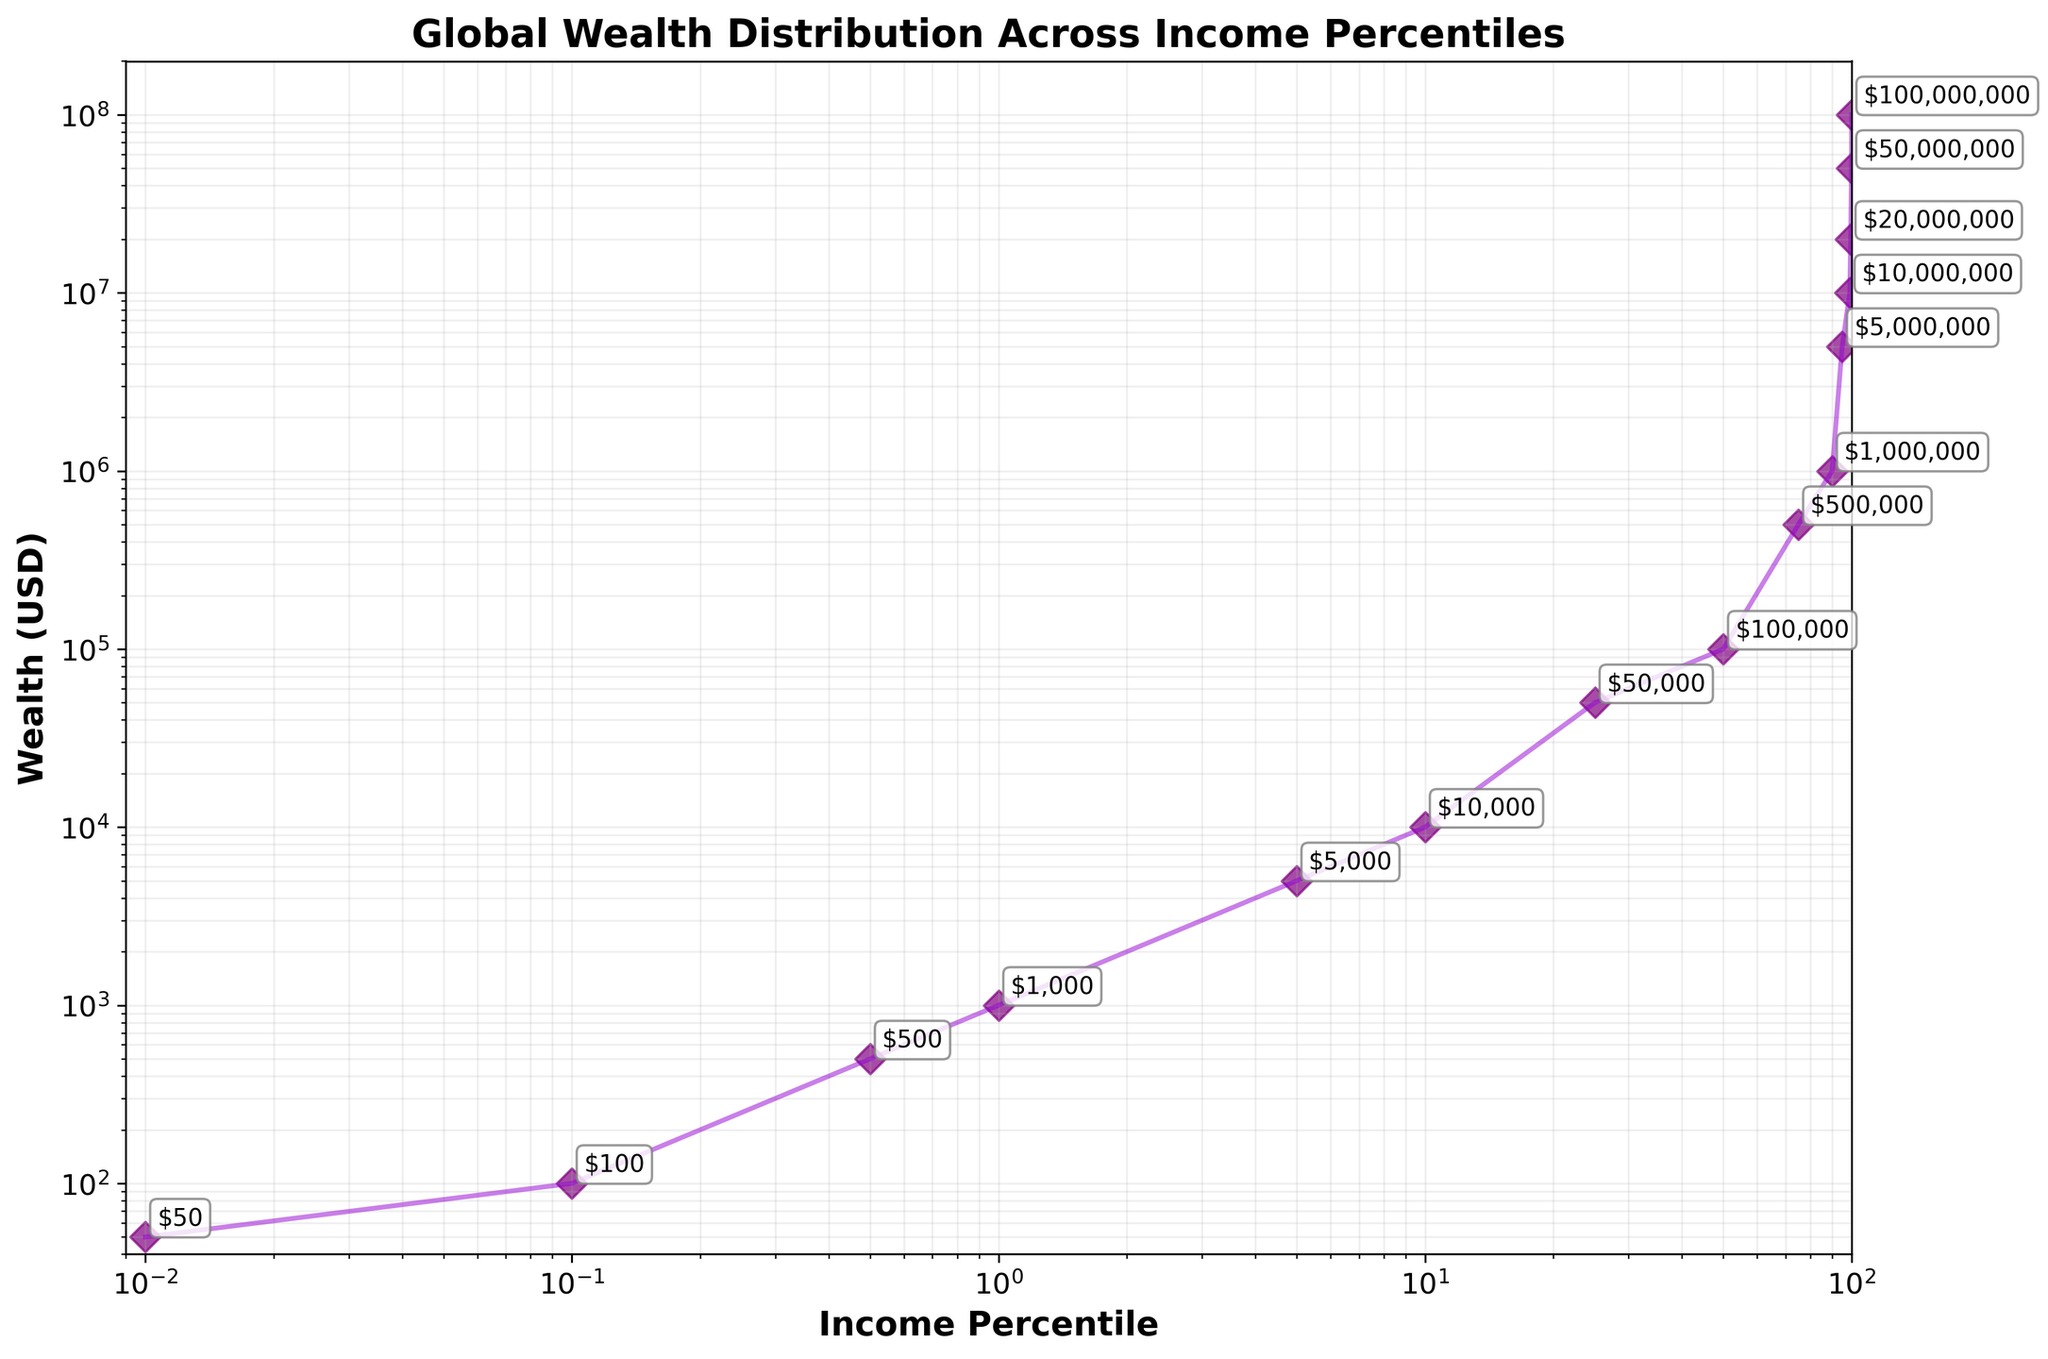What is the title of the plot? The title of the plot is typically found at the top and is clearly labeled as such. In this case, the title reads "Global Wealth Distribution Across Income Percentiles."
Answer: Global Wealth Distribution Across Income Percentiles What are the axis labels on the figure? Axis labels provide information about what each axis represents. They are found next to the respective axes. Here, the x-axis is labeled "Income Percentile" and the y-axis is labeled "Wealth (USD)."
Answer: Income Percentile and Wealth (USD) What is the wealth at the 25th income percentile? To find this, locate the 25th percentile on the x-axis (Income Percentile) and trace it up to the point on the plot. The corresponding y-axis (Wealth in USD) value should be noted.
Answer: 50,000 USD What is the difference in wealth between the 99.9th and 99.5th percentiles? Locate the 99.9th and 99.5th percentiles on the x-axis, then find their respective wealth values on the y-axis. Subtract the wealth value of the 99.5th percentile from the wealth value of the 99.9th percentile: 50,000,000 - 20,000,000.
Answer: 30,000,000 USD Between the 5th and 10th percentiles, which income percentile has higher wealth? Compare the wealth values at the 5th percentile and the 10th percentile by locating both points on the x-axis and tracing them to their respective y-axis values. The 10th percentile wealth (10,000 USD) is greater than the 5th percentile wealth (5,000 USD).
Answer: 10th percentile What is the average wealth between the 0.5th, 1st, and 5th percentiles? Find the wealth values for each percentile: 0.5th (500 USD), 1st (1,000 USD), and 5th (5,000 USD). Sum these values and divide by the number of percentiles: (500 + 1,000 + 5,000) / 3.
Answer: 2,166.67 USD How does the wealth distribution appear on the plot? The points and lines plotted show a clear increasing trend, indicating wealth significantly increases at higher income percentiles. Given the log-log scale, this creates a steep curve as you move to the right.
Answer: Steeply increasing trend What is typically the wealth of the top 1% (99th percentile) of income earners? Locate the 99th income percentile on the x-axis and trace it up to the corresponding point. The y-axis value represents the wealth: 10,000,000 USD.
Answer: 10,000,000 USD How does the wealth at the 50th percentile compare with that at the 90th percentile? Identify the wealth values at both the 50th (100,000 USD) and 90th (1,000,000 USD) percentiles on the plot. Compare the values directly. The wealth at the 90th percentile is much higher.
Answer: Wealth at the 90th percentile is much higher than at the 50th percentile What is the smallest and largest wealth value displayed in the figure? By examining the plot and reading the annotations, the smallest wealth value is at the 0.01th percentile (50 USD) and the largest is at the 99.99th percentile (100,000,000 USD).
Answer: 50 USD and 100,000,000 USD 